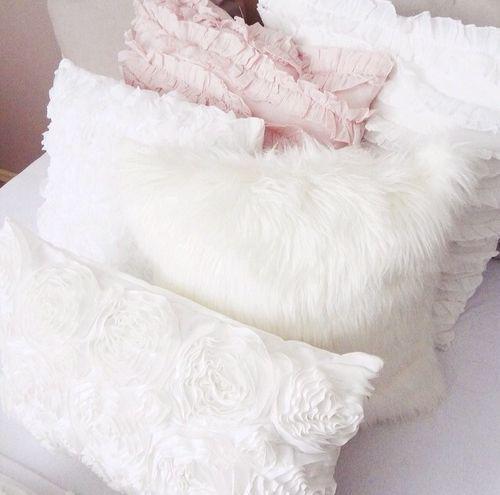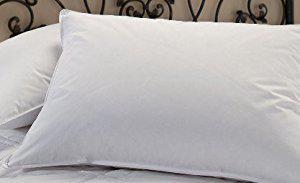The first image is the image on the left, the second image is the image on the right. Evaluate the accuracy of this statement regarding the images: "There is something pink on a bed.". Is it true? Answer yes or no. Yes. 